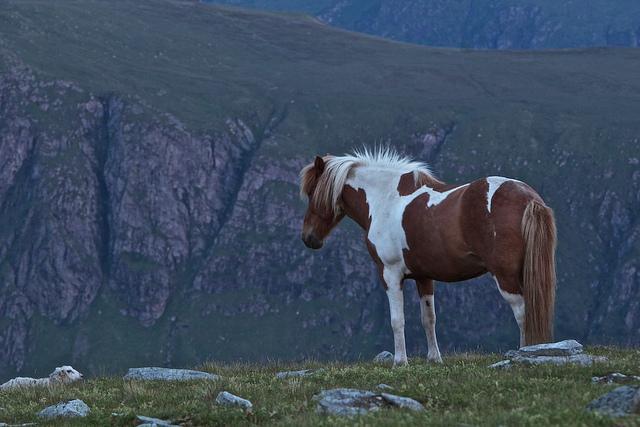Is there anyone here?
Answer briefly. No. What color is the horse?
Concise answer only. Brown and white. How old is this pony?
Short answer required. Young. Are all four of the horse's feet on the ground?
Quick response, please. Yes. What is the possible danger to the horse?
Give a very brief answer. Falling. Are there shadows on the ground?
Short answer required. No. What animal is this?
Quick response, please. Horse. What is this horse doing?
Give a very brief answer. Standing. 